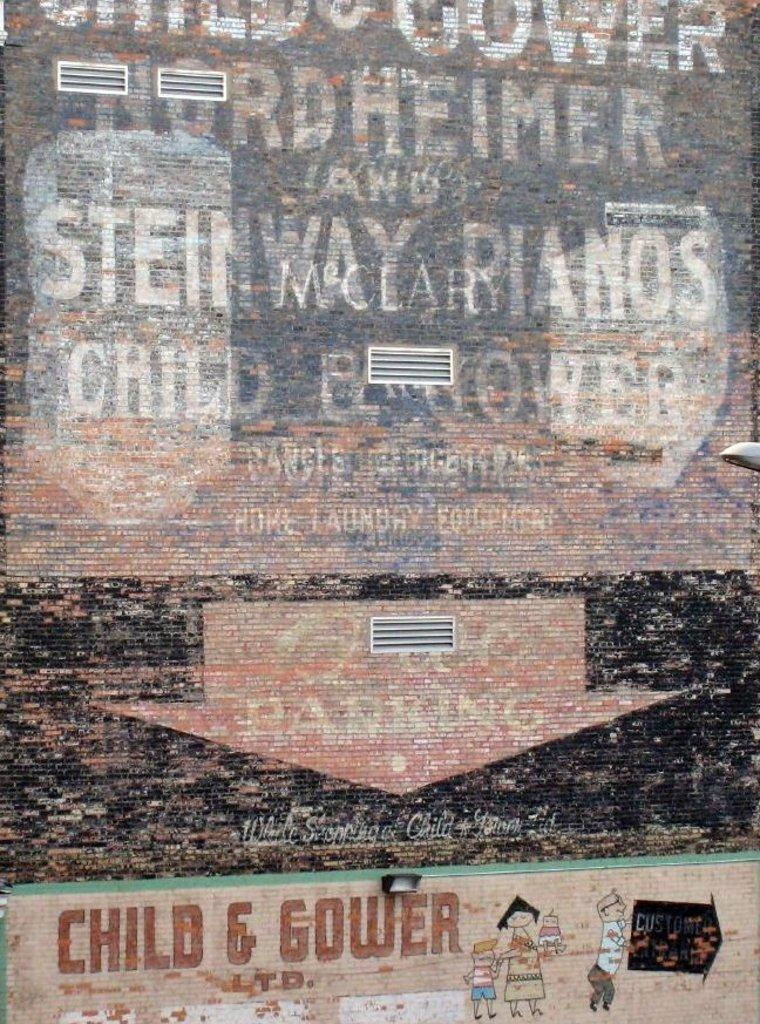<image>
Relay a brief, clear account of the picture shown. a building that says 'child & gower' at the bottom of it 